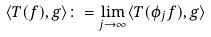<formula> <loc_0><loc_0><loc_500><loc_500>\langle T ( f ) , g \rangle \colon = \lim _ { j \to \infty } \langle T ( \phi _ { j } f ) , g \rangle</formula> 